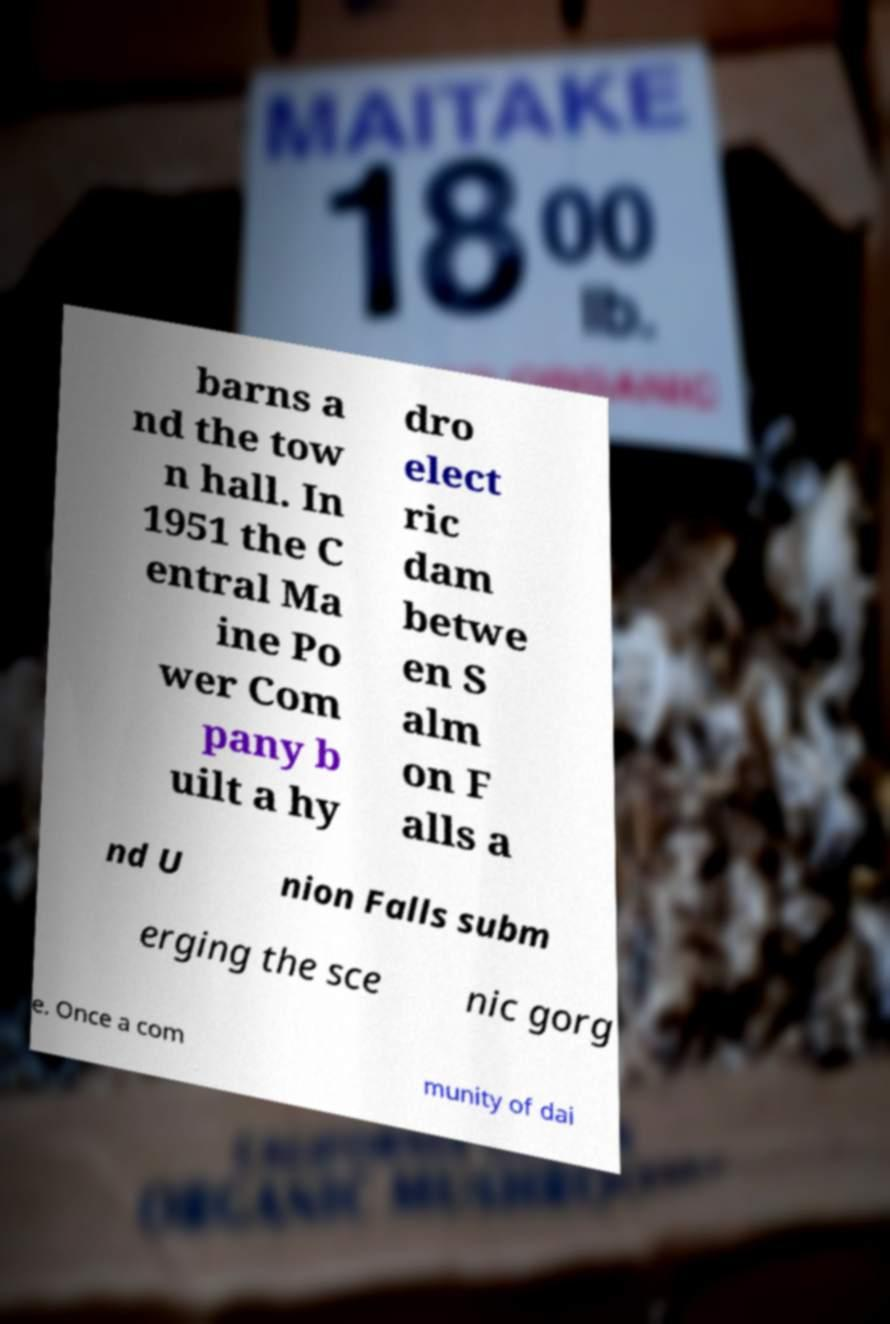Please identify and transcribe the text found in this image. barns a nd the tow n hall. In 1951 the C entral Ma ine Po wer Com pany b uilt a hy dro elect ric dam betwe en S alm on F alls a nd U nion Falls subm erging the sce nic gorg e. Once a com munity of dai 